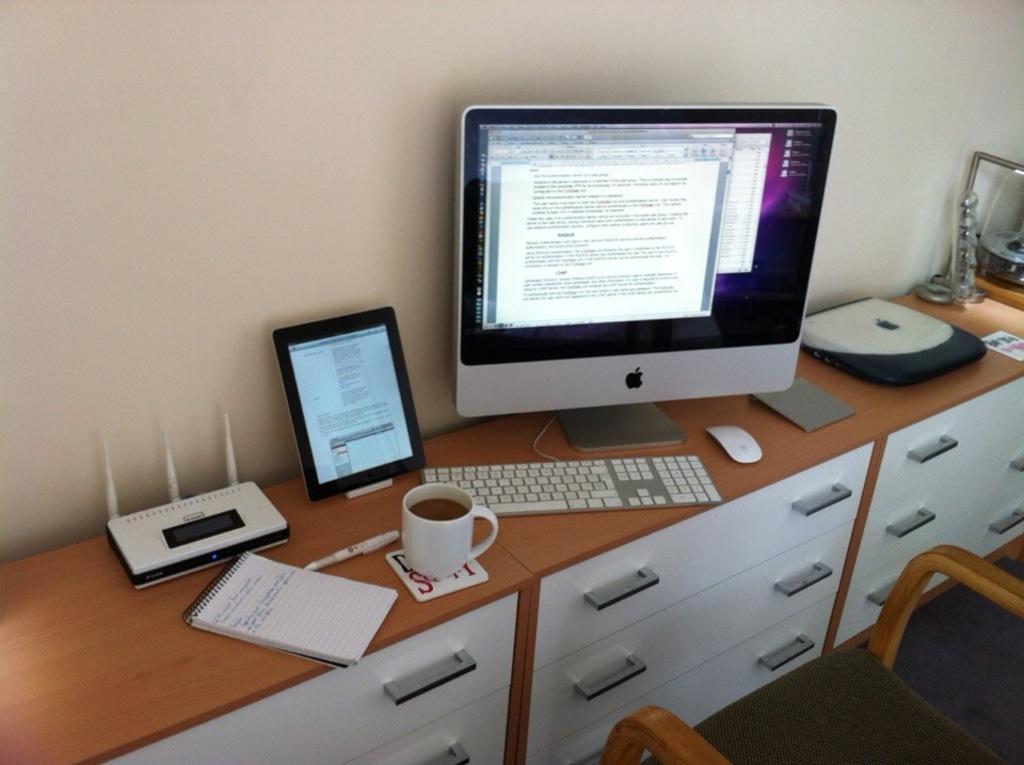Can you describe this image briefly? In this image I can see a big table on which a book, cpu, monitor, keyboard, mouse and few objects are placed. On the right bottom of the image there is a chair. 